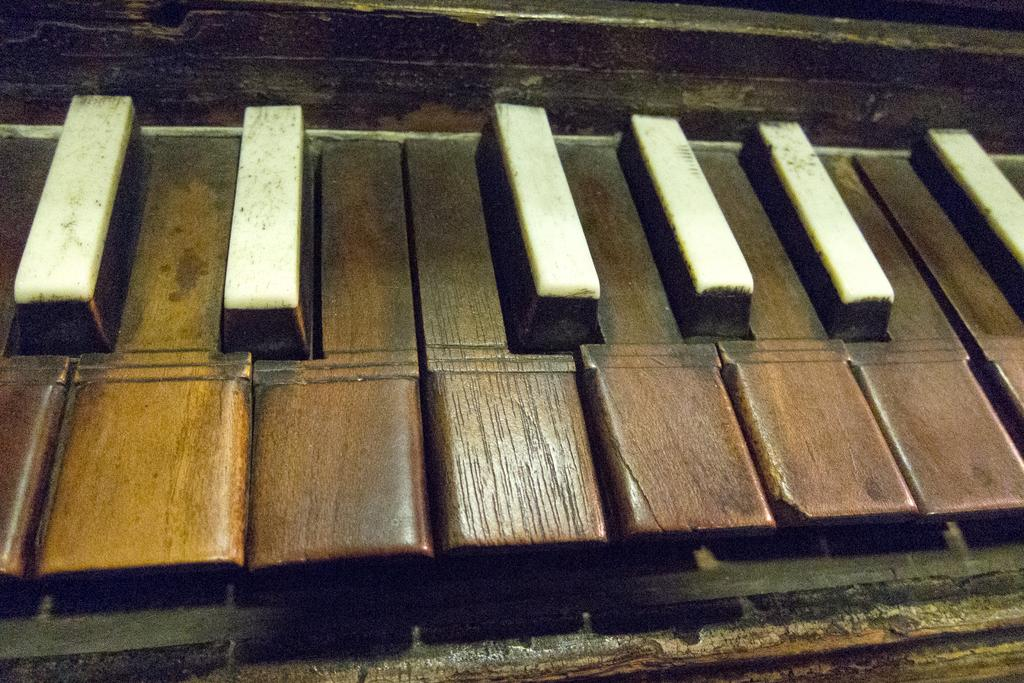What type of musical instrument is present in the image? There is a wooden piano in the image. Can you describe the material of the piano? The piano is made of wood. What verse is being recited by the head in the image? There is no head or verse present in the image; it only features a wooden piano. 